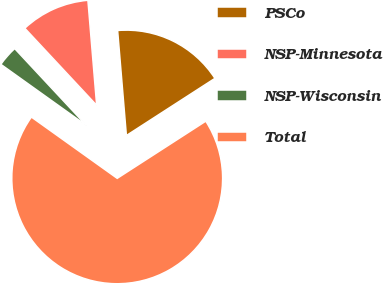<chart> <loc_0><loc_0><loc_500><loc_500><pie_chart><fcel>PSCo<fcel>NSP-Minnesota<fcel>NSP-Wisconsin<fcel>Total<nl><fcel>17.2%<fcel>10.62%<fcel>3.18%<fcel>69.0%<nl></chart> 